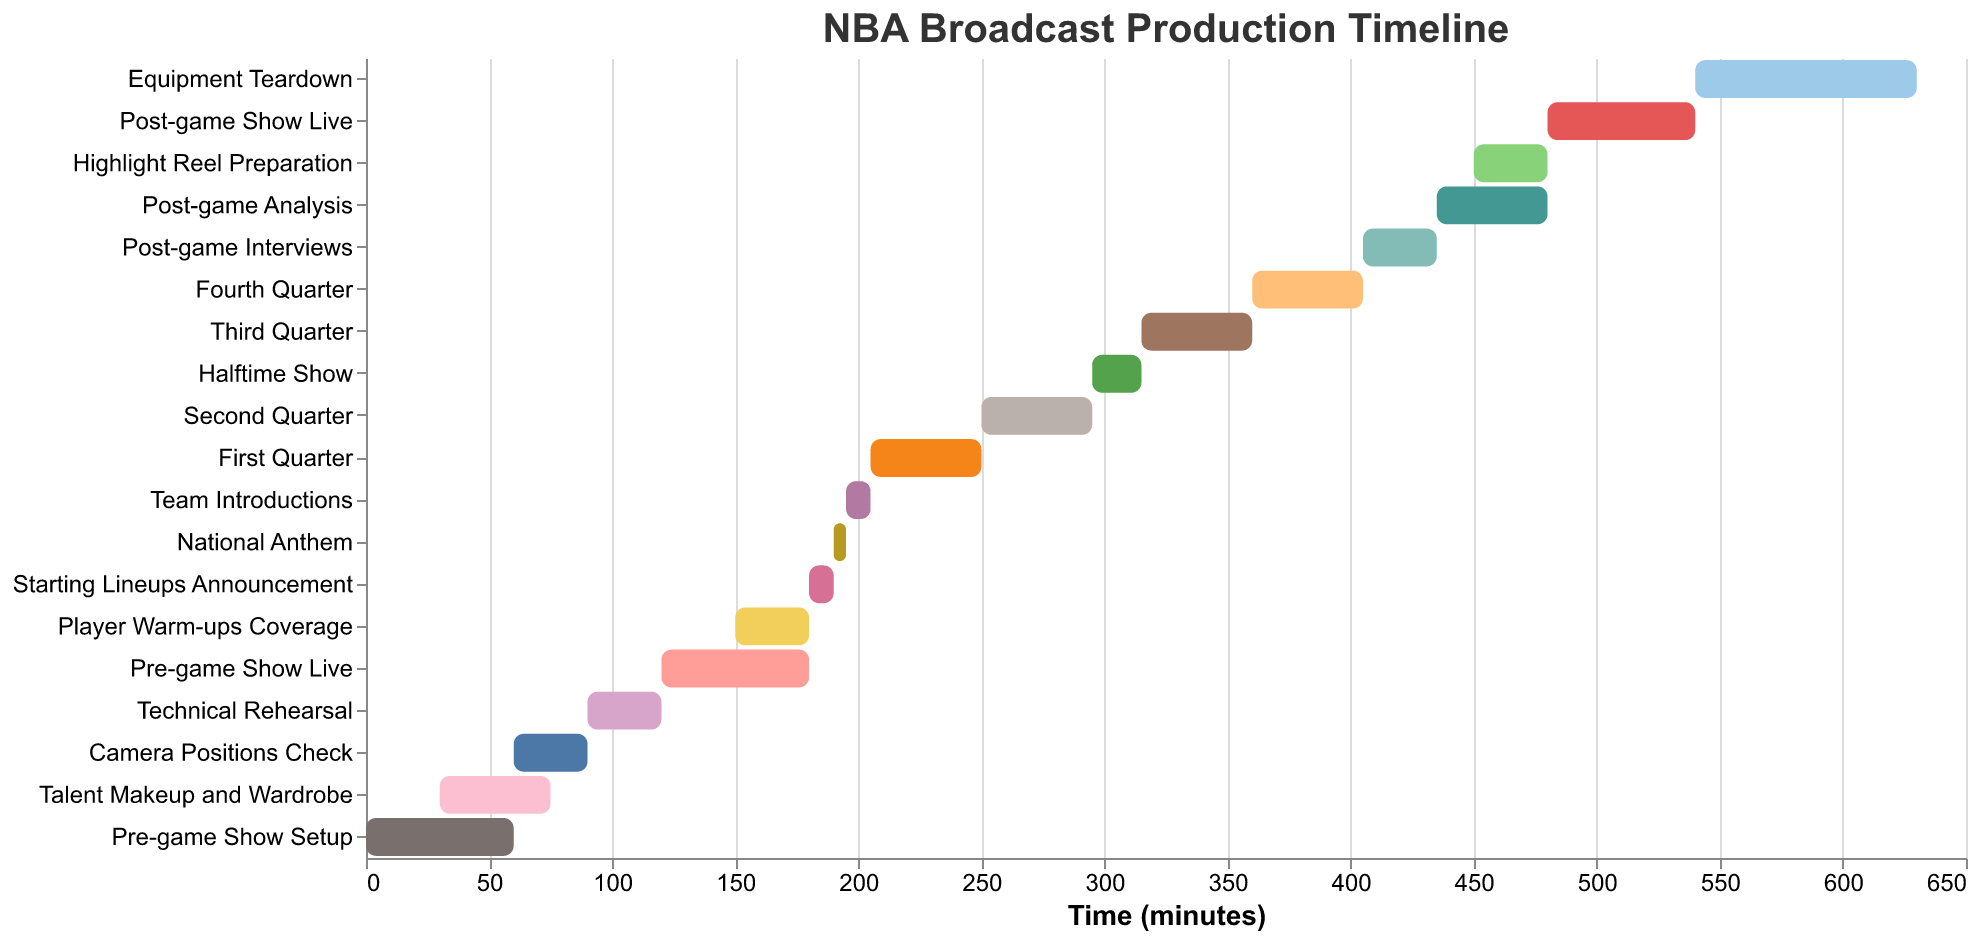What is the title of the Gantt Chart? The title can be found at the top center of the chart. It reads "NBA Broadcast Production Timeline."
Answer: NBA Broadcast Production Timeline When does the Pre-game Show Setup start and how long does it last? We can see in the chart that the Pre-game Show Setup starts at time 0 and lasts for 60 minutes, as indicated by the length of the corresponding bar on the timeline.
Answer: Starts at 0, lasts 60 minutes What task overlaps with both the Pre-game Show Setup and Talent Makeup and Wardrobe? Referring to the timeline, Camera Positions Check starts at 60 minutes, overlapping both the Pre-game Show Setup (ending at 60 minutes) and Talent Makeup and Wardrobe (starting at 30 minutes and ending at 75 minutes).
Answer: Camera Positions Check What is the total duration of the pre-game activities before the Player Warm-ups Coverage? Pre-game activities include Pre-game Show Setup, Talent Makeup and Wardrobe, Camera Positions Check, Technical Rehearsal, and Pre-game Show Live. Summing their durations: 60 + 45 + 30 + 30 + 60 = 225 minutes.
Answer: 225 minutes What time does the National Anthem start? The National Anthem starts at 190 minutes, as shown by the start time on the chart.
Answer: 190 minutes Which task takes the longest time during the game segments? The longest game segment is one of the quarters. Each quarter lasts 45 minutes. Upon reviewing, the duration for any single quarter (First, Second, Third, Fourth Quarter) is the same, i.e., 45 minutes.
Answer: Each Quarter (45 min) After which activity does the Halftime Show begin? According to the Gantt chart, the Halftime Show starts immediately after the Second Quarter.
Answer: Second Quarter What is the first task directly after the game ends? The game ends after the Fourth Quarter (ending at 405 minutes). The next task is Post-game Interviews starting at 405 minutes.
Answer: Post-game Interviews What is the combined duration of all post-game activities? Post-game activities include Post-game Interviews, Post-game Analysis, Highlight Reel Preparation, Post-game Show Live, Equipment Teardown. Summing their durations: 30 + 45 + 30 + 60 + 90 = 255 minutes.
Answer: 255 minutes Which task directly follows the Technical Rehearsal, and what is its duration? Immediately following the Technical Rehearsal (ending at 120 minutes) is the Pre-game Show Live, which lasts for 60 minutes.
Answer: Pre-game Show Live (60 mins) 